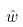Convert formula to latex. <formula><loc_0><loc_0><loc_500><loc_500>\hat { w }</formula> 